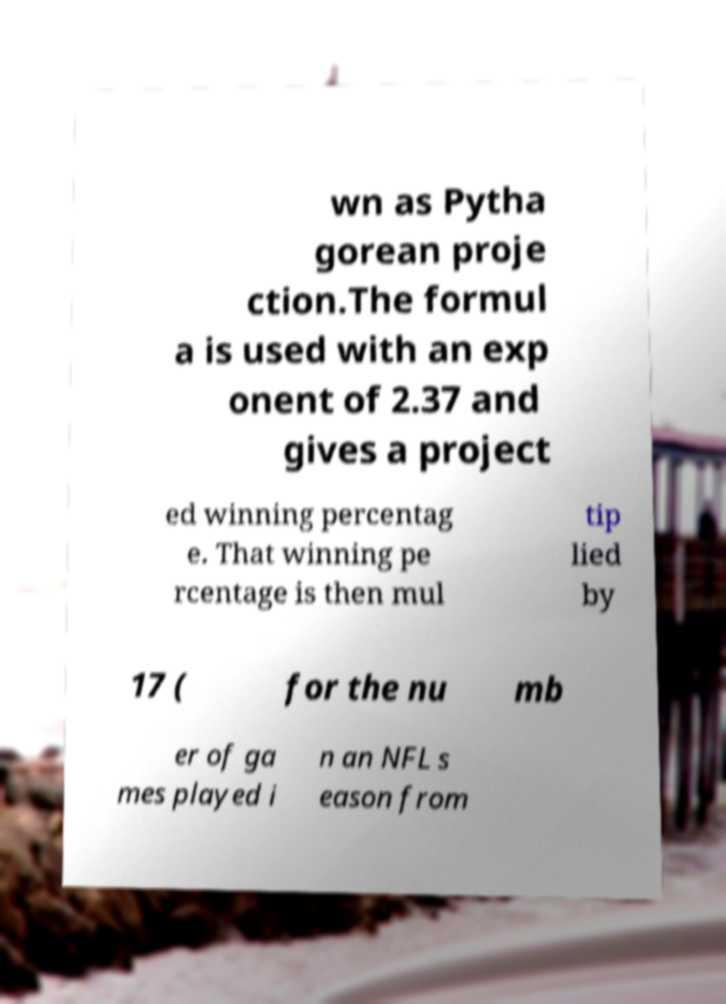Please identify and transcribe the text found in this image. wn as Pytha gorean proje ction.The formul a is used with an exp onent of 2.37 and gives a project ed winning percentag e. That winning pe rcentage is then mul tip lied by 17 ( for the nu mb er of ga mes played i n an NFL s eason from 